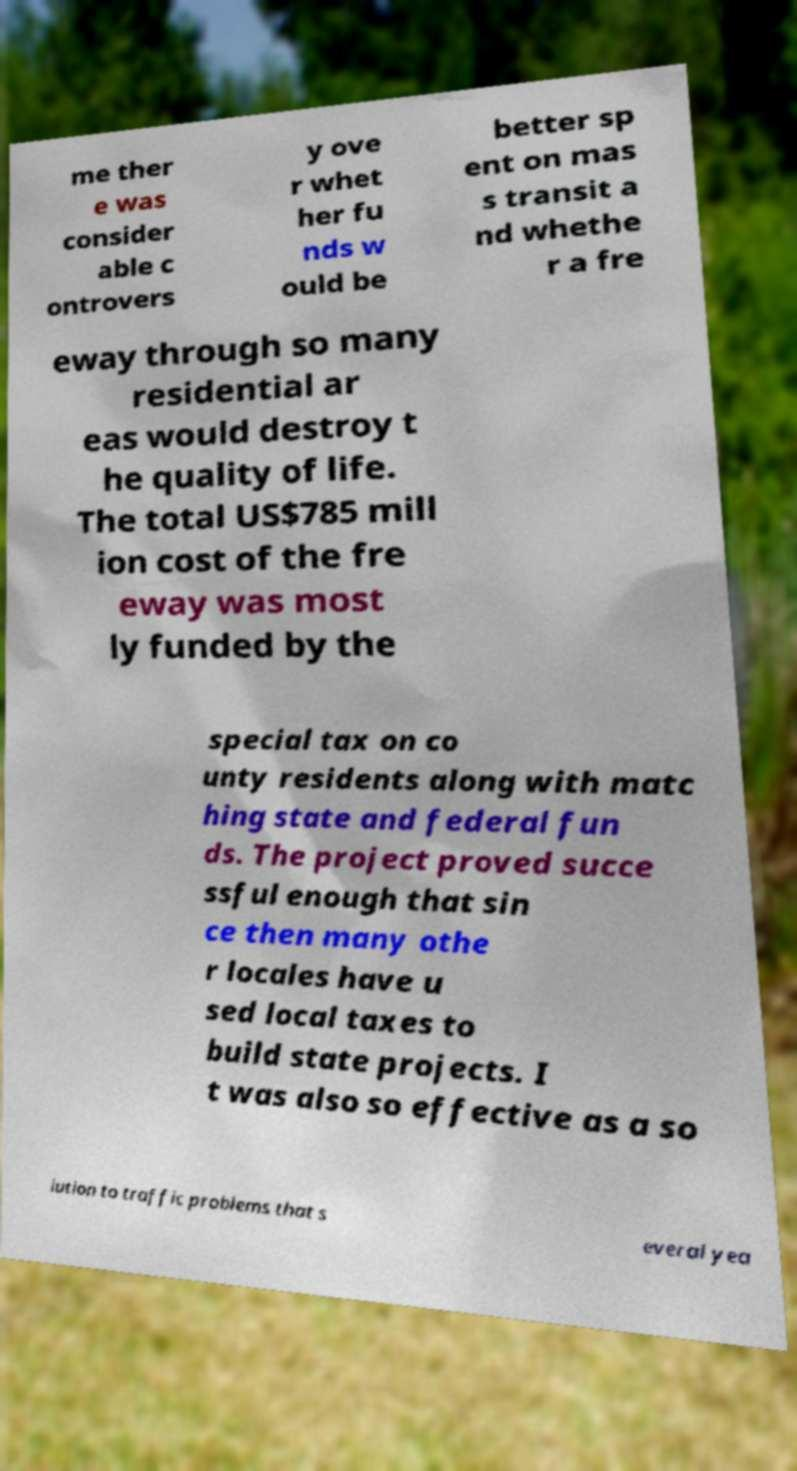Can you accurately transcribe the text from the provided image for me? me ther e was consider able c ontrovers y ove r whet her fu nds w ould be better sp ent on mas s transit a nd whethe r a fre eway through so many residential ar eas would destroy t he quality of life. The total US$785 mill ion cost of the fre eway was most ly funded by the special tax on co unty residents along with matc hing state and federal fun ds. The project proved succe ssful enough that sin ce then many othe r locales have u sed local taxes to build state projects. I t was also so effective as a so lution to traffic problems that s everal yea 